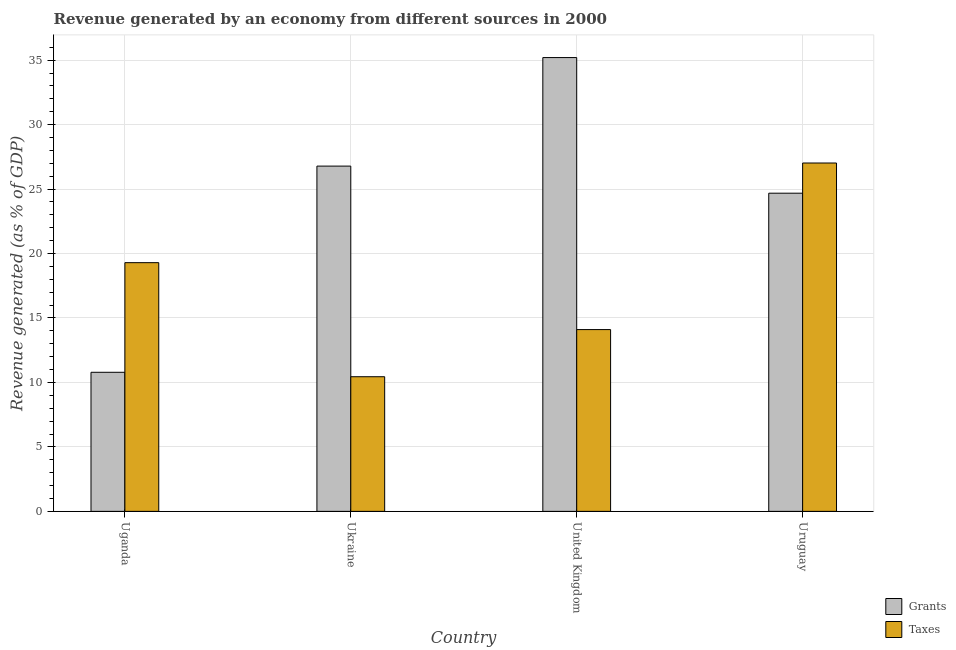How many different coloured bars are there?
Your answer should be very brief. 2. What is the label of the 2nd group of bars from the left?
Your response must be concise. Ukraine. In how many cases, is the number of bars for a given country not equal to the number of legend labels?
Your answer should be compact. 0. What is the revenue generated by taxes in Ukraine?
Offer a very short reply. 10.44. Across all countries, what is the maximum revenue generated by grants?
Your answer should be very brief. 35.2. Across all countries, what is the minimum revenue generated by taxes?
Offer a very short reply. 10.44. In which country was the revenue generated by taxes maximum?
Your answer should be compact. Uruguay. In which country was the revenue generated by taxes minimum?
Provide a succinct answer. Ukraine. What is the total revenue generated by grants in the graph?
Offer a terse response. 97.45. What is the difference between the revenue generated by grants in Ukraine and that in Uruguay?
Provide a short and direct response. 2.1. What is the difference between the revenue generated by grants in Uganda and the revenue generated by taxes in Uruguay?
Give a very brief answer. -16.23. What is the average revenue generated by taxes per country?
Provide a succinct answer. 17.71. What is the difference between the revenue generated by grants and revenue generated by taxes in Uruguay?
Provide a succinct answer. -2.34. What is the ratio of the revenue generated by grants in Uganda to that in United Kingdom?
Provide a short and direct response. 0.31. What is the difference between the highest and the second highest revenue generated by grants?
Offer a terse response. 8.42. What is the difference between the highest and the lowest revenue generated by grants?
Offer a very short reply. 24.41. Is the sum of the revenue generated by taxes in Ukraine and United Kingdom greater than the maximum revenue generated by grants across all countries?
Offer a terse response. No. What does the 1st bar from the left in Ukraine represents?
Ensure brevity in your answer.  Grants. What does the 1st bar from the right in Uruguay represents?
Provide a short and direct response. Taxes. How many countries are there in the graph?
Keep it short and to the point. 4. Does the graph contain grids?
Offer a terse response. Yes. How many legend labels are there?
Give a very brief answer. 2. What is the title of the graph?
Offer a terse response. Revenue generated by an economy from different sources in 2000. What is the label or title of the X-axis?
Provide a succinct answer. Country. What is the label or title of the Y-axis?
Keep it short and to the point. Revenue generated (as % of GDP). What is the Revenue generated (as % of GDP) in Grants in Uganda?
Your answer should be compact. 10.79. What is the Revenue generated (as % of GDP) in Taxes in Uganda?
Your response must be concise. 19.29. What is the Revenue generated (as % of GDP) in Grants in Ukraine?
Offer a terse response. 26.78. What is the Revenue generated (as % of GDP) of Taxes in Ukraine?
Your answer should be compact. 10.44. What is the Revenue generated (as % of GDP) of Grants in United Kingdom?
Your answer should be very brief. 35.2. What is the Revenue generated (as % of GDP) in Taxes in United Kingdom?
Offer a terse response. 14.1. What is the Revenue generated (as % of GDP) in Grants in Uruguay?
Offer a terse response. 24.68. What is the Revenue generated (as % of GDP) in Taxes in Uruguay?
Your response must be concise. 27.02. Across all countries, what is the maximum Revenue generated (as % of GDP) of Grants?
Make the answer very short. 35.2. Across all countries, what is the maximum Revenue generated (as % of GDP) of Taxes?
Offer a terse response. 27.02. Across all countries, what is the minimum Revenue generated (as % of GDP) in Grants?
Your answer should be compact. 10.79. Across all countries, what is the minimum Revenue generated (as % of GDP) of Taxes?
Your answer should be compact. 10.44. What is the total Revenue generated (as % of GDP) of Grants in the graph?
Your answer should be very brief. 97.45. What is the total Revenue generated (as % of GDP) in Taxes in the graph?
Provide a short and direct response. 70.86. What is the difference between the Revenue generated (as % of GDP) of Grants in Uganda and that in Ukraine?
Offer a very short reply. -15.99. What is the difference between the Revenue generated (as % of GDP) of Taxes in Uganda and that in Ukraine?
Provide a short and direct response. 8.85. What is the difference between the Revenue generated (as % of GDP) of Grants in Uganda and that in United Kingdom?
Provide a succinct answer. -24.41. What is the difference between the Revenue generated (as % of GDP) of Taxes in Uganda and that in United Kingdom?
Offer a terse response. 5.19. What is the difference between the Revenue generated (as % of GDP) in Grants in Uganda and that in Uruguay?
Your response must be concise. -13.89. What is the difference between the Revenue generated (as % of GDP) in Taxes in Uganda and that in Uruguay?
Provide a short and direct response. -7.73. What is the difference between the Revenue generated (as % of GDP) of Grants in Ukraine and that in United Kingdom?
Give a very brief answer. -8.42. What is the difference between the Revenue generated (as % of GDP) in Taxes in Ukraine and that in United Kingdom?
Provide a short and direct response. -3.66. What is the difference between the Revenue generated (as % of GDP) in Grants in Ukraine and that in Uruguay?
Make the answer very short. 2.1. What is the difference between the Revenue generated (as % of GDP) of Taxes in Ukraine and that in Uruguay?
Make the answer very short. -16.58. What is the difference between the Revenue generated (as % of GDP) in Grants in United Kingdom and that in Uruguay?
Your response must be concise. 10.52. What is the difference between the Revenue generated (as % of GDP) in Taxes in United Kingdom and that in Uruguay?
Give a very brief answer. -12.92. What is the difference between the Revenue generated (as % of GDP) in Grants in Uganda and the Revenue generated (as % of GDP) in Taxes in Ukraine?
Your response must be concise. 0.34. What is the difference between the Revenue generated (as % of GDP) of Grants in Uganda and the Revenue generated (as % of GDP) of Taxes in United Kingdom?
Offer a terse response. -3.31. What is the difference between the Revenue generated (as % of GDP) in Grants in Uganda and the Revenue generated (as % of GDP) in Taxes in Uruguay?
Offer a very short reply. -16.23. What is the difference between the Revenue generated (as % of GDP) in Grants in Ukraine and the Revenue generated (as % of GDP) in Taxes in United Kingdom?
Provide a succinct answer. 12.68. What is the difference between the Revenue generated (as % of GDP) in Grants in Ukraine and the Revenue generated (as % of GDP) in Taxes in Uruguay?
Make the answer very short. -0.24. What is the difference between the Revenue generated (as % of GDP) in Grants in United Kingdom and the Revenue generated (as % of GDP) in Taxes in Uruguay?
Offer a terse response. 8.18. What is the average Revenue generated (as % of GDP) in Grants per country?
Make the answer very short. 24.36. What is the average Revenue generated (as % of GDP) of Taxes per country?
Offer a very short reply. 17.71. What is the difference between the Revenue generated (as % of GDP) in Grants and Revenue generated (as % of GDP) in Taxes in Uganda?
Your response must be concise. -8.5. What is the difference between the Revenue generated (as % of GDP) of Grants and Revenue generated (as % of GDP) of Taxes in Ukraine?
Your answer should be compact. 16.34. What is the difference between the Revenue generated (as % of GDP) in Grants and Revenue generated (as % of GDP) in Taxes in United Kingdom?
Make the answer very short. 21.1. What is the difference between the Revenue generated (as % of GDP) of Grants and Revenue generated (as % of GDP) of Taxes in Uruguay?
Give a very brief answer. -2.34. What is the ratio of the Revenue generated (as % of GDP) in Grants in Uganda to that in Ukraine?
Offer a very short reply. 0.4. What is the ratio of the Revenue generated (as % of GDP) of Taxes in Uganda to that in Ukraine?
Your response must be concise. 1.85. What is the ratio of the Revenue generated (as % of GDP) in Grants in Uganda to that in United Kingdom?
Make the answer very short. 0.31. What is the ratio of the Revenue generated (as % of GDP) in Taxes in Uganda to that in United Kingdom?
Your answer should be very brief. 1.37. What is the ratio of the Revenue generated (as % of GDP) in Grants in Uganda to that in Uruguay?
Keep it short and to the point. 0.44. What is the ratio of the Revenue generated (as % of GDP) in Taxes in Uganda to that in Uruguay?
Keep it short and to the point. 0.71. What is the ratio of the Revenue generated (as % of GDP) in Grants in Ukraine to that in United Kingdom?
Provide a short and direct response. 0.76. What is the ratio of the Revenue generated (as % of GDP) in Taxes in Ukraine to that in United Kingdom?
Your answer should be very brief. 0.74. What is the ratio of the Revenue generated (as % of GDP) of Grants in Ukraine to that in Uruguay?
Make the answer very short. 1.09. What is the ratio of the Revenue generated (as % of GDP) in Taxes in Ukraine to that in Uruguay?
Your response must be concise. 0.39. What is the ratio of the Revenue generated (as % of GDP) in Grants in United Kingdom to that in Uruguay?
Provide a short and direct response. 1.43. What is the ratio of the Revenue generated (as % of GDP) in Taxes in United Kingdom to that in Uruguay?
Provide a succinct answer. 0.52. What is the difference between the highest and the second highest Revenue generated (as % of GDP) of Grants?
Provide a short and direct response. 8.42. What is the difference between the highest and the second highest Revenue generated (as % of GDP) in Taxes?
Provide a short and direct response. 7.73. What is the difference between the highest and the lowest Revenue generated (as % of GDP) of Grants?
Offer a very short reply. 24.41. What is the difference between the highest and the lowest Revenue generated (as % of GDP) in Taxes?
Your answer should be very brief. 16.58. 